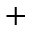Convert formula to latex. <formula><loc_0><loc_0><loc_500><loc_500>^ { + }</formula> 